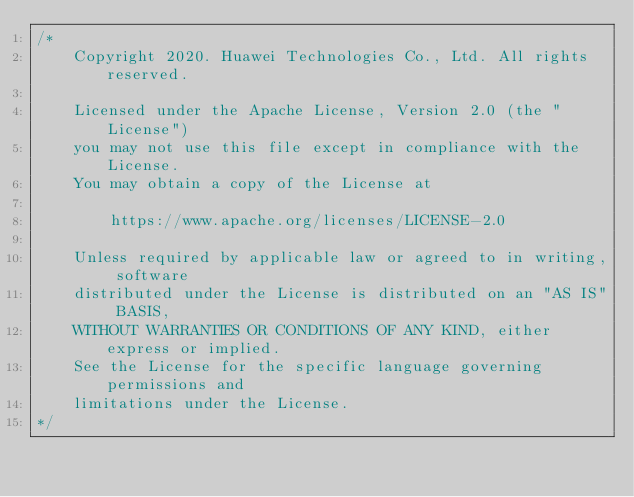Convert code to text. <code><loc_0><loc_0><loc_500><loc_500><_Dart_>/*
    Copyright 2020. Huawei Technologies Co., Ltd. All rights reserved.

    Licensed under the Apache License, Version 2.0 (the "License")
    you may not use this file except in compliance with the License.
    You may obtain a copy of the License at

        https://www.apache.org/licenses/LICENSE-2.0

    Unless required by applicable law or agreed to in writing, software
    distributed under the License is distributed on an "AS IS" BASIS,
    WITHOUT WARRANTIES OR CONDITIONS OF ANY KIND, either express or implied.
    See the License for the specific language governing permissions and
    limitations under the License.
*/
</code> 